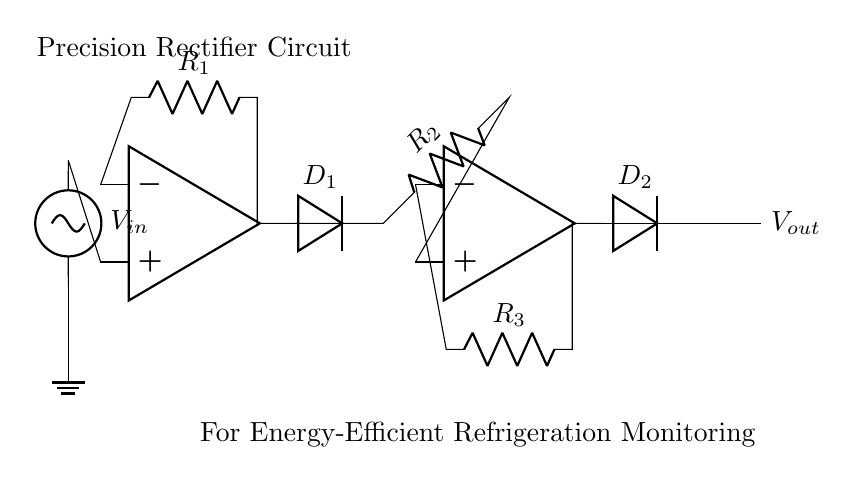What are the main components of the circuit? The main components include two operational amplifiers, three resistors, and two diodes, which are essential in constructing the precision rectifier circuit.
Answer: Operational amplifiers, resistors, diodes What is the purpose of the diodes in this circuit? The diodes allow current to flow in only one direction, enabling the circuit to rectify the input AC signal into a DC output, which is crucial for accurate power monitoring.
Answer: Rectification How many resistors are present in the circuit? There are three resistors connected in the circuit; they are important for gain setting and controlling the flow of current in various parts of the circuit.
Answer: Three What is the output voltage signal type? The output voltage is DC, as the purpose of the precision rectifier is to convert an alternating current input into a direct current output, reflecting accurate power usage.
Answer: DC How do the operational amplifiers affect the performance of this rectifier? The operational amplifiers amplify the input signal and improve the precision of the rectification process, allowing for accurate readings crucial for energy efficiency monitoring in refrigeration units.
Answer: Improve precision What type of rectifier is implemented in this circuit? This circuit implements a precision rectifier, which is designed to provide accurate voltage measurement near zero input signal levels, making it ideal for energy-efficient applications.
Answer: Precision rectifier What is the significance of using a precision rectifier in energy monitoring? A precision rectifier allows for more accurate detection of low-level signals from refrigeration units, which is vital for monitoring energy usage and enhancing efficiency.
Answer: Accurate detection of low-level signals 